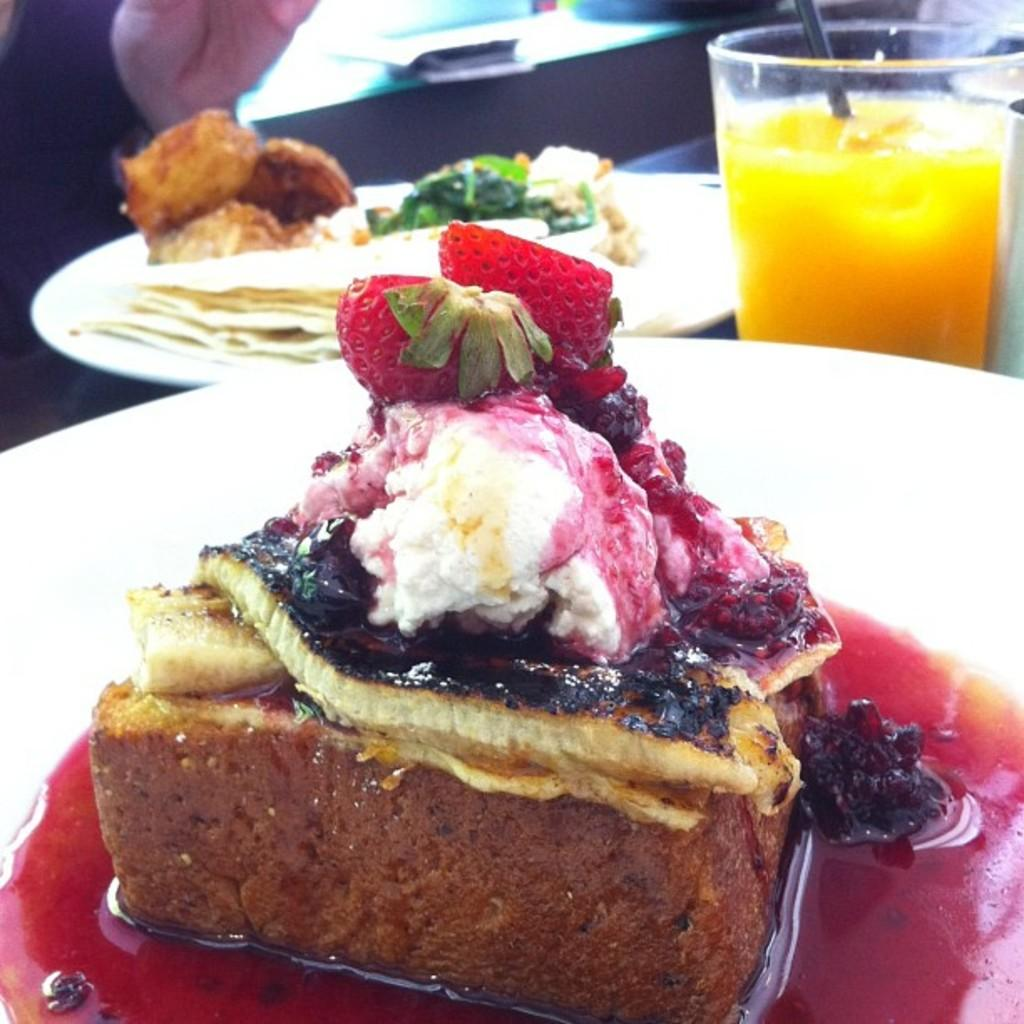What is the main food item in the image? There is a cake in the image. How is the cake presented? The cake is on a plate. What is a noticeable feature of the cake? There is cream on the cake, and there are strawberries on it. What other food item can be seen beside the cake? There is a plate with a food item beside the cake. What is in the glass in the image? There is a liquid in the glass. How much attention does the cake receive from the line in the image? There is no line present in the image, and the cake is not interacting with any attention-seeking elements. 